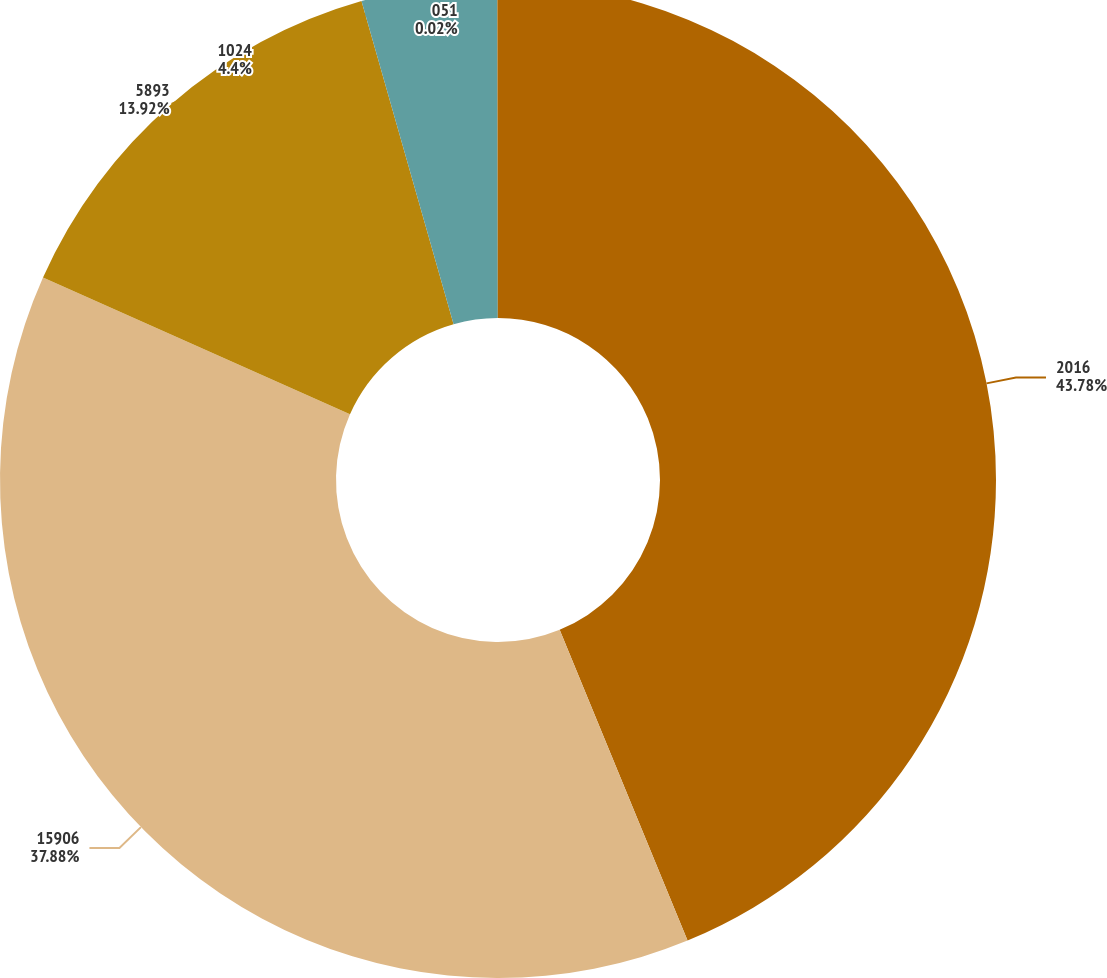Convert chart. <chart><loc_0><loc_0><loc_500><loc_500><pie_chart><fcel>2016<fcel>15906<fcel>5893<fcel>1024<fcel>051<nl><fcel>43.79%<fcel>37.88%<fcel>13.92%<fcel>4.4%<fcel>0.02%<nl></chart> 